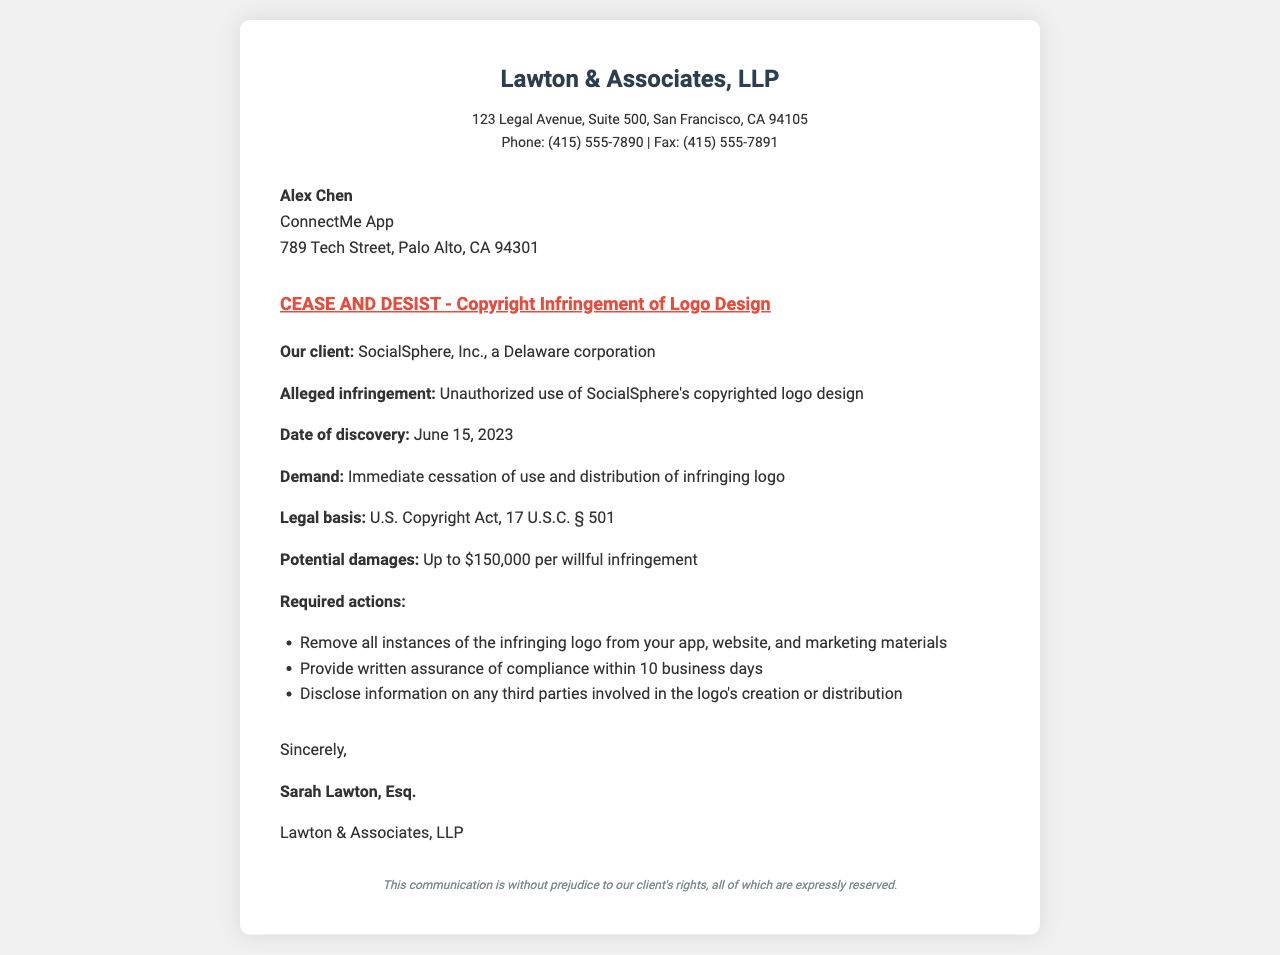What is the name of the sender's law firm? The sender's law firm is mentioned in the header of the document.
Answer: Lawton & Associates, LLP Who is the recipient of the cease and desist letter? The recipient's name and organization are listed under the recipient section of the document.
Answer: Alex Chen What is the alleged infringement related to? The specific infringement is stated in the body of the document.
Answer: Unauthorized use of SocialSphere's copyrighted logo design When was the infringement discovered? The date of discovery is explicitly mentioned in the body of the document.
Answer: June 15, 2023 What is the maximum potential damage for infringement? This information is provided in the body section, highlighting the potential legal consequences.
Answer: Up to $150,000 per willful infringement What action must be taken within 10 business days? The required action is detailed under the required actions section of the document.
Answer: Provide written assurance of compliance Which law governs the alleged copyright infringement? The legal basis is included in the document with a specific reference.
Answer: U.S. Copyright Act, 17 U.S.C. § 501 What should be done with the infringing logo? The document outlines a specific action regarding the logo under required actions.
Answer: Remove all instances of the infringing logo What is implied about the sender's rights? This information can be found in the footer of the fax, indicating the status of the communication.
Answer: All of which are expressly reserved 